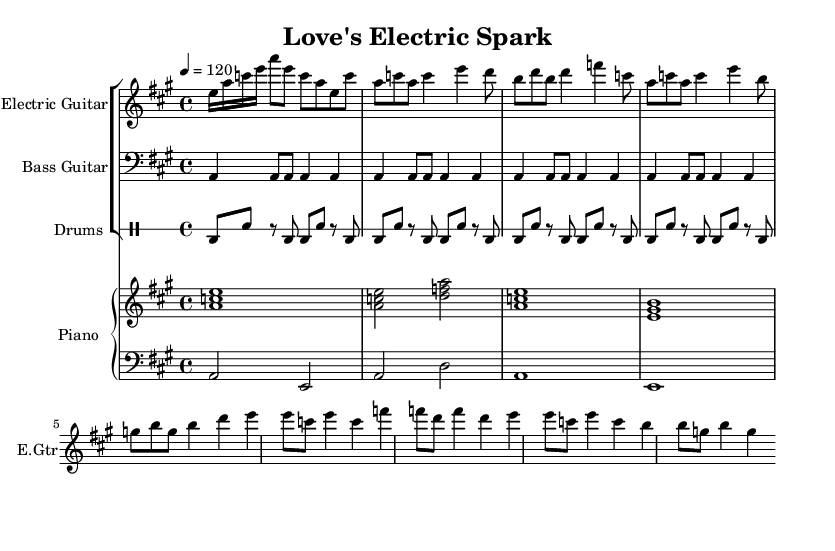What is the key signature of this music? The key signature is A major, which has three sharps (F#, C#, and G#). You can determine this by looking at the key signature indicated at the beginning of the music.
Answer: A major What is the time signature of this sheet music? The time signature is 4/4, which means there are four beats in each measure, and the quarter note gets one beat. This can be found notated at the beginning of the score.
Answer: 4/4 What is the tempo marking for this piece? The tempo marking is indicated as 120 beats per minute. This is noted at the beginning of the score with "4 = 120".
Answer: 120 How many measures are in the verse section? The verse section consists of 4 measures, as can be counted by analyzing the notation that contains the melody for the verse which is visually separated from the chorus.
Answer: 4 What is the primary instrument for the melody? The primary instrument for the melody is the Electric Guitar, which is labeled prominently at the start of its staff.
Answer: Electric Guitar What chords are played in the chorus? The chords played in the chorus are A, D, E, and B. By examining the right-hand piano part during the chorus, these chords can be identified based on the notes played together.
Answer: A, D, E, B What rhythmic pattern is used in the drums throughout the piece? The rhythmic pattern in the drums is consistent with alternating bass and snare hits. This can be observed and counted in both the intro and the repeated drum part used in the verse and chorus.
Answer: Bass and Snare 